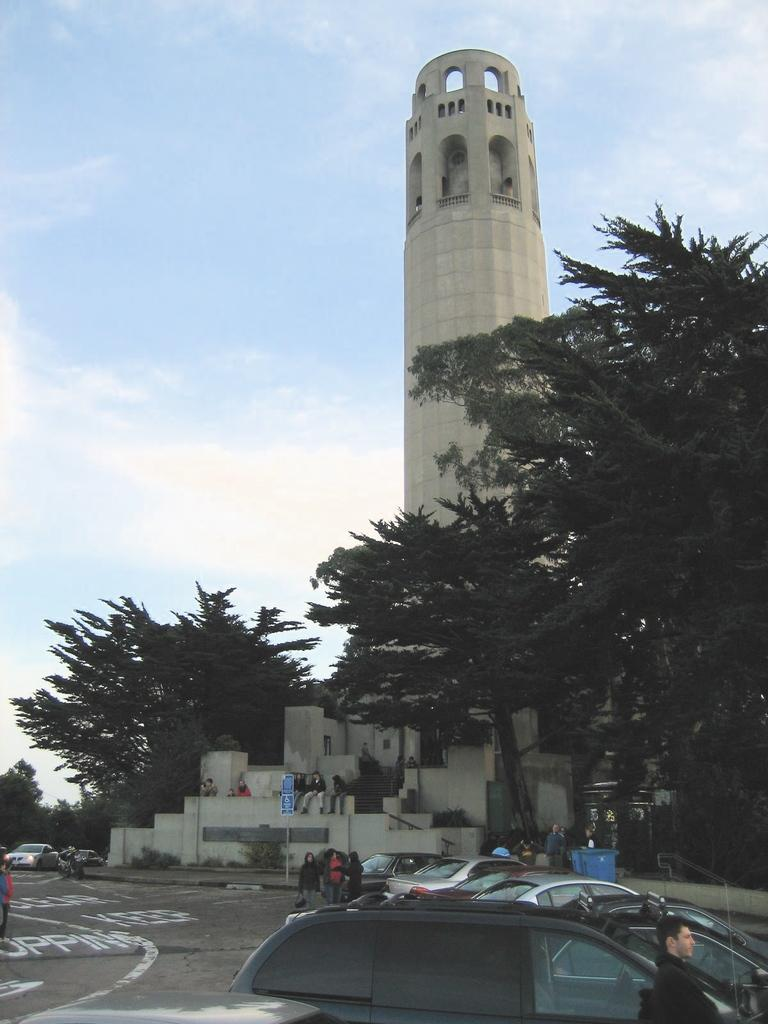What type of vehicles can be seen on the road in the image? There are cars on the road in the image. Are there any people present on the road in the image? Yes, there are persons on the road in the image. What type of natural elements can be seen in the image? There are trees in the image. What type of structure is visible in the image? There is a building in the image. What is visible in the background of the image? The sky is visible in the background of the image, and clouds are present in the sky. What type of shoes are the committee members wearing in the image? There is no committee or shoes present in the image; it features cars, persons, trees, a building, and a sky with clouds. 